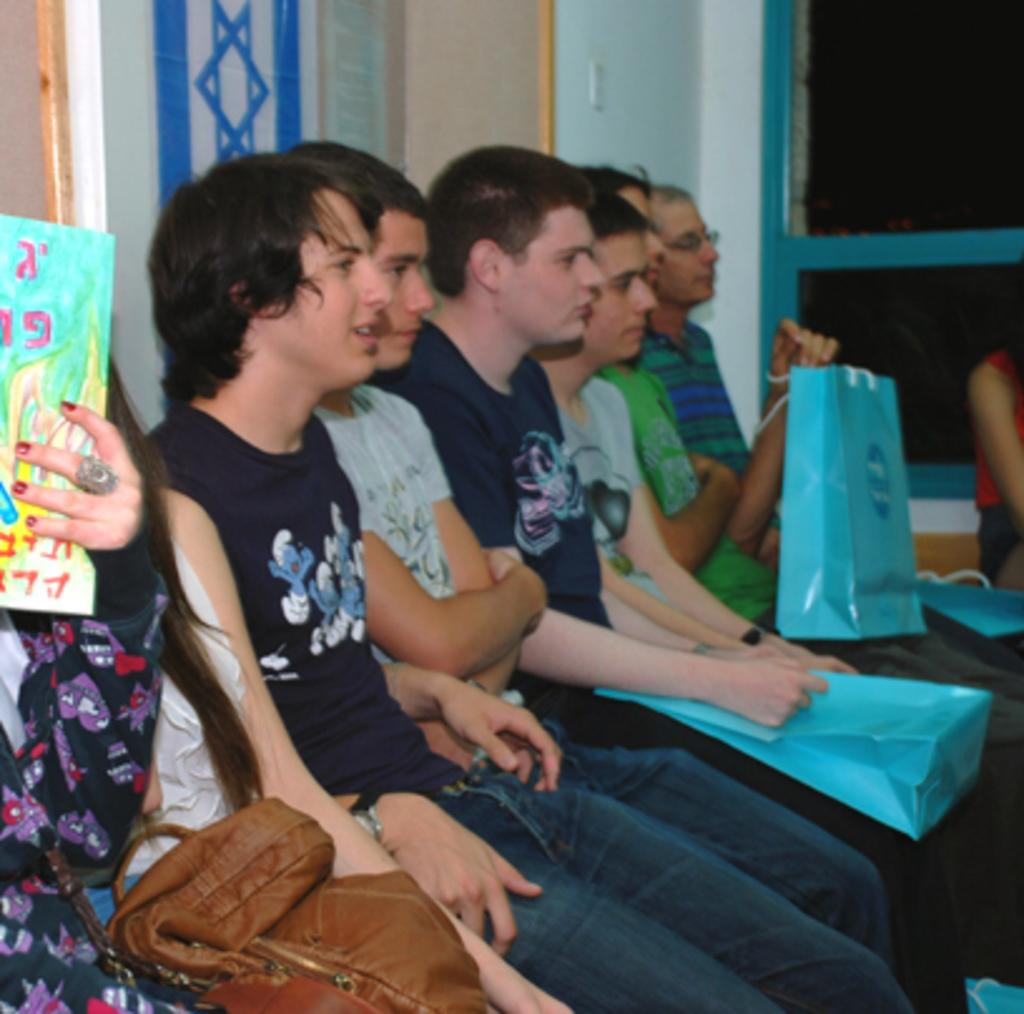What are the people in the image doing? The people in the image are sitting on chairs. What are the people holding while sitting on the chairs? The people are holding bags in their hands. What can be seen behind the people in the image? There is a wall visible in the image. Is there any entrance or exit in the image? Yes, there is a door in the image. What type of expansion is taking place in the image? There is no expansion taking place in the image. Is there an army present in the image? There is no army present in the image. 